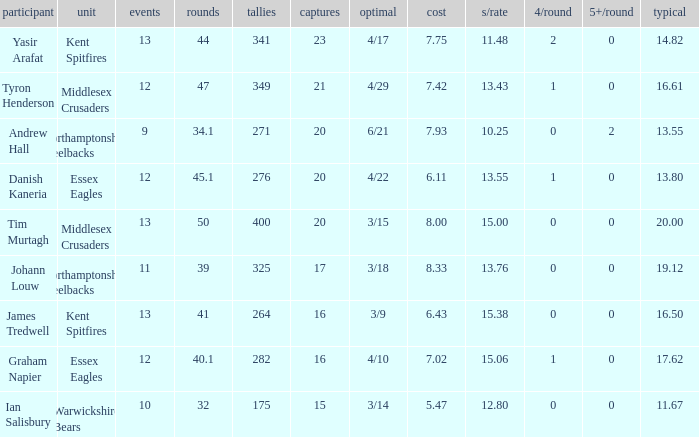Name the least matches for runs being 276 12.0. 